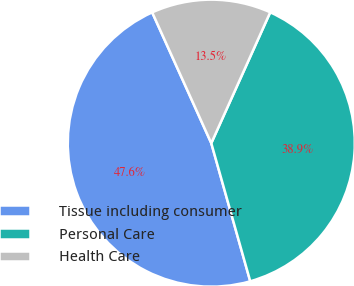Convert chart to OTSL. <chart><loc_0><loc_0><loc_500><loc_500><pie_chart><fcel>Tissue including consumer<fcel>Personal Care<fcel>Health Care<nl><fcel>47.62%<fcel>38.89%<fcel>13.49%<nl></chart> 